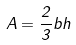Convert formula to latex. <formula><loc_0><loc_0><loc_500><loc_500>A = \frac { 2 } { 3 } b h</formula> 